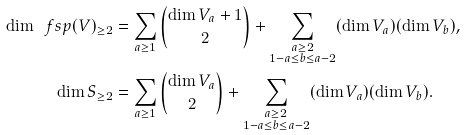Convert formula to latex. <formula><loc_0><loc_0><loc_500><loc_500>\dim \ f s p ( V ) _ { \geq 2 } & = \sum _ { a \geq 1 } \binom { \dim V _ { a } + 1 } { 2 } + \sum _ { \substack { a \geq 2 \\ 1 - a \leq b \leq a - 2 } } ( \dim V _ { a } ) ( \dim V _ { b } ) , \\ \dim S _ { \geq 2 } & = \sum _ { a \geq 1 } \binom { \dim V _ { a } } { 2 } + \sum _ { \substack { a \geq 2 \\ 1 - a \leq b \leq a - 2 } } ( \dim V _ { a } ) ( \dim V _ { b } ) .</formula> 